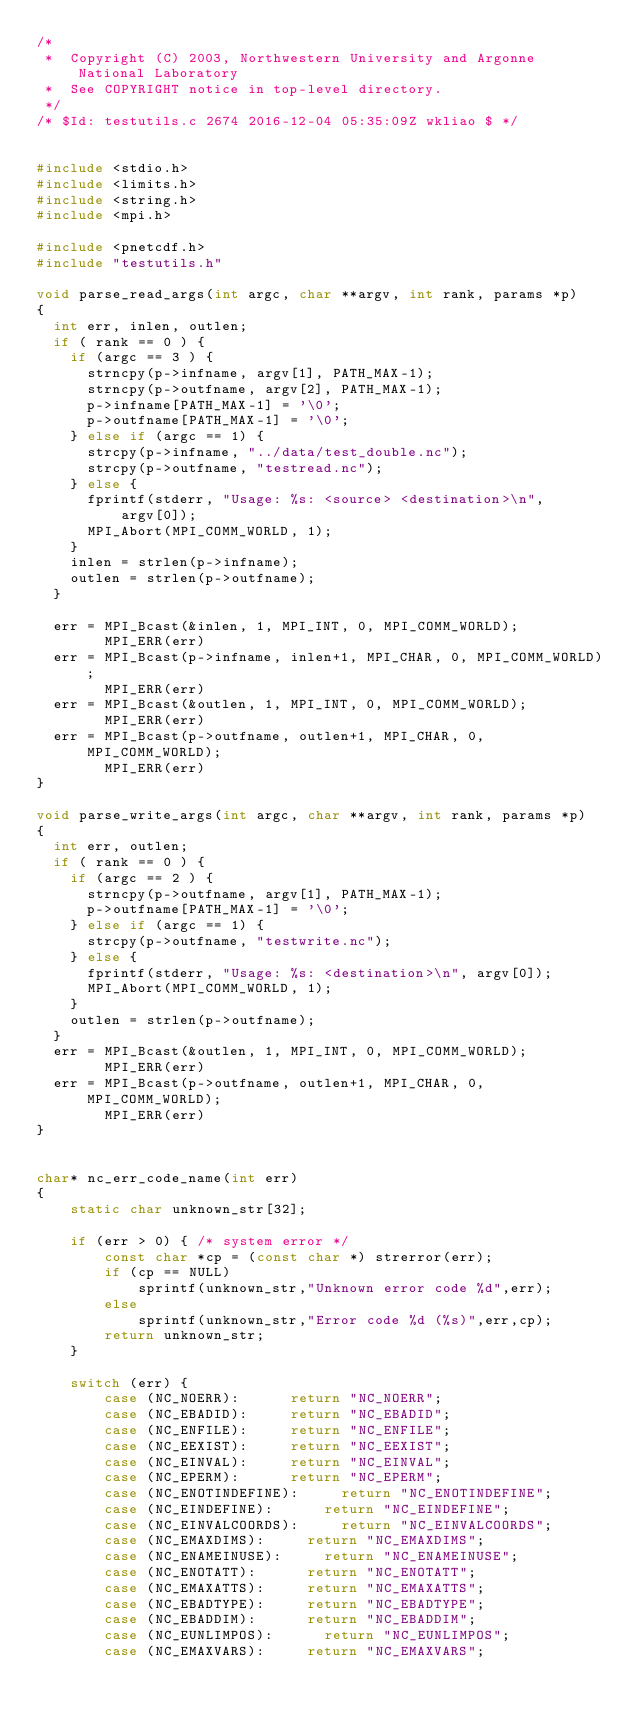Convert code to text. <code><loc_0><loc_0><loc_500><loc_500><_C_>/*
 *  Copyright (C) 2003, Northwestern University and Argonne National Laboratory
 *  See COPYRIGHT notice in top-level directory.
 */
/* $Id: testutils.c 2674 2016-12-04 05:35:09Z wkliao $ */


#include <stdio.h>
#include <limits.h>
#include <string.h>
#include <mpi.h>

#include <pnetcdf.h>
#include "testutils.h"

void parse_read_args(int argc, char **argv, int rank, params *p)
{
	int err, inlen, outlen;
	if ( rank == 0 ) {
		if (argc == 3 ) {
			strncpy(p->infname, argv[1], PATH_MAX-1);
			strncpy(p->outfname, argv[2], PATH_MAX-1);
			p->infname[PATH_MAX-1] = '\0';
			p->outfname[PATH_MAX-1] = '\0';
		} else if (argc == 1) {
			strcpy(p->infname, "../data/test_double.nc");
			strcpy(p->outfname, "testread.nc");
		} else {
			fprintf(stderr, "Usage: %s: <source> <destination>\n", 
					argv[0]);
			MPI_Abort(MPI_COMM_WORLD, 1);
		}
		inlen = strlen(p->infname);
		outlen = strlen(p->outfname);
	}

	err = MPI_Bcast(&inlen, 1, MPI_INT, 0, MPI_COMM_WORLD);
        MPI_ERR(err)
	err = MPI_Bcast(p->infname, inlen+1, MPI_CHAR, 0, MPI_COMM_WORLD);
        MPI_ERR(err)
	err = MPI_Bcast(&outlen, 1, MPI_INT, 0, MPI_COMM_WORLD);
        MPI_ERR(err)
	err = MPI_Bcast(p->outfname, outlen+1, MPI_CHAR, 0, MPI_COMM_WORLD);
        MPI_ERR(err)
}

void parse_write_args(int argc, char **argv, int rank, params *p)
{
	int err, outlen;
	if ( rank == 0 ) {
		if (argc == 2 ) {
			strncpy(p->outfname, argv[1], PATH_MAX-1);
			p->outfname[PATH_MAX-1] = '\0';
		} else if (argc == 1) {
			strcpy(p->outfname, "testwrite.nc");
		} else {
			fprintf(stderr, "Usage: %s: <destination>\n", argv[0]);
			MPI_Abort(MPI_COMM_WORLD, 1);
		}
		outlen = strlen(p->outfname);
	}
	err = MPI_Bcast(&outlen, 1, MPI_INT, 0, MPI_COMM_WORLD);
        MPI_ERR(err)
	err = MPI_Bcast(p->outfname, outlen+1, MPI_CHAR, 0, MPI_COMM_WORLD);
        MPI_ERR(err)
}


char* nc_err_code_name(int err)
{
    static char unknown_str[32];

    if (err > 0) { /* system error */
        const char *cp = (const char *) strerror(err);
        if (cp == NULL)
            sprintf(unknown_str,"Unknown error code %d",err);
        else
            sprintf(unknown_str,"Error code %d (%s)",err,cp);
        return unknown_str;
    }

    switch (err) {
        case (NC_NOERR):			return "NC_NOERR";
        case (NC_EBADID):			return "NC_EBADID";
        case (NC_ENFILE):			return "NC_ENFILE";
        case (NC_EEXIST):			return "NC_EEXIST";
        case (NC_EINVAL):			return "NC_EINVAL";
        case (NC_EPERM):			return "NC_EPERM";
        case (NC_ENOTINDEFINE):			return "NC_ENOTINDEFINE";
        case (NC_EINDEFINE):			return "NC_EINDEFINE";
        case (NC_EINVALCOORDS):			return "NC_EINVALCOORDS";
        case (NC_EMAXDIMS):			return "NC_EMAXDIMS";
        case (NC_ENAMEINUSE):			return "NC_ENAMEINUSE";
        case (NC_ENOTATT):			return "NC_ENOTATT";
        case (NC_EMAXATTS):			return "NC_EMAXATTS";
        case (NC_EBADTYPE):			return "NC_EBADTYPE";
        case (NC_EBADDIM):			return "NC_EBADDIM";
        case (NC_EUNLIMPOS):			return "NC_EUNLIMPOS";
        case (NC_EMAXVARS):			return "NC_EMAXVARS";</code> 